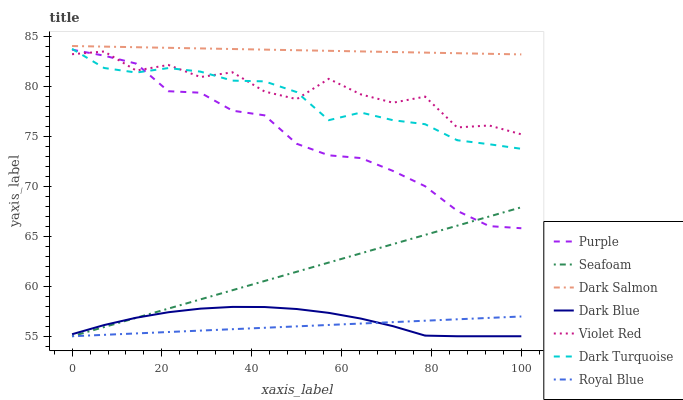Does Purple have the minimum area under the curve?
Answer yes or no. No. Does Purple have the maximum area under the curve?
Answer yes or no. No. Is Purple the smoothest?
Answer yes or no. No. Is Purple the roughest?
Answer yes or no. No. Does Purple have the lowest value?
Answer yes or no. No. Does Purple have the highest value?
Answer yes or no. No. Is Royal Blue less than Purple?
Answer yes or no. Yes. Is Violet Red greater than Royal Blue?
Answer yes or no. Yes. Does Royal Blue intersect Purple?
Answer yes or no. No. 